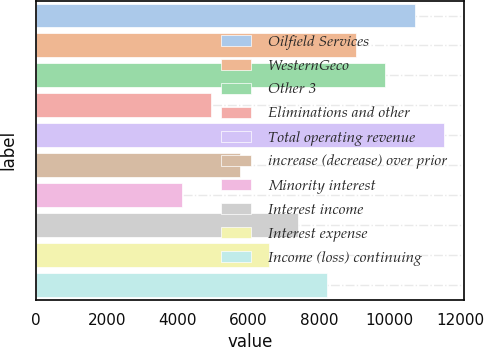<chart> <loc_0><loc_0><loc_500><loc_500><bar_chart><fcel>Oilfield Services<fcel>WesternGeco<fcel>Other 3<fcel>Eliminations and other<fcel>Total operating revenue<fcel>increase (decrease) over prior<fcel>Minority interest<fcel>Interest income<fcel>Interest expense<fcel>Income (loss) continuing<nl><fcel>10700.3<fcel>9054.11<fcel>9877.2<fcel>4938.66<fcel>11523.4<fcel>5761.75<fcel>4115.57<fcel>7407.93<fcel>6584.84<fcel>8231.02<nl></chart> 